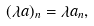Convert formula to latex. <formula><loc_0><loc_0><loc_500><loc_500>( \lambda a ) _ { n } = \lambda a _ { n } ,</formula> 